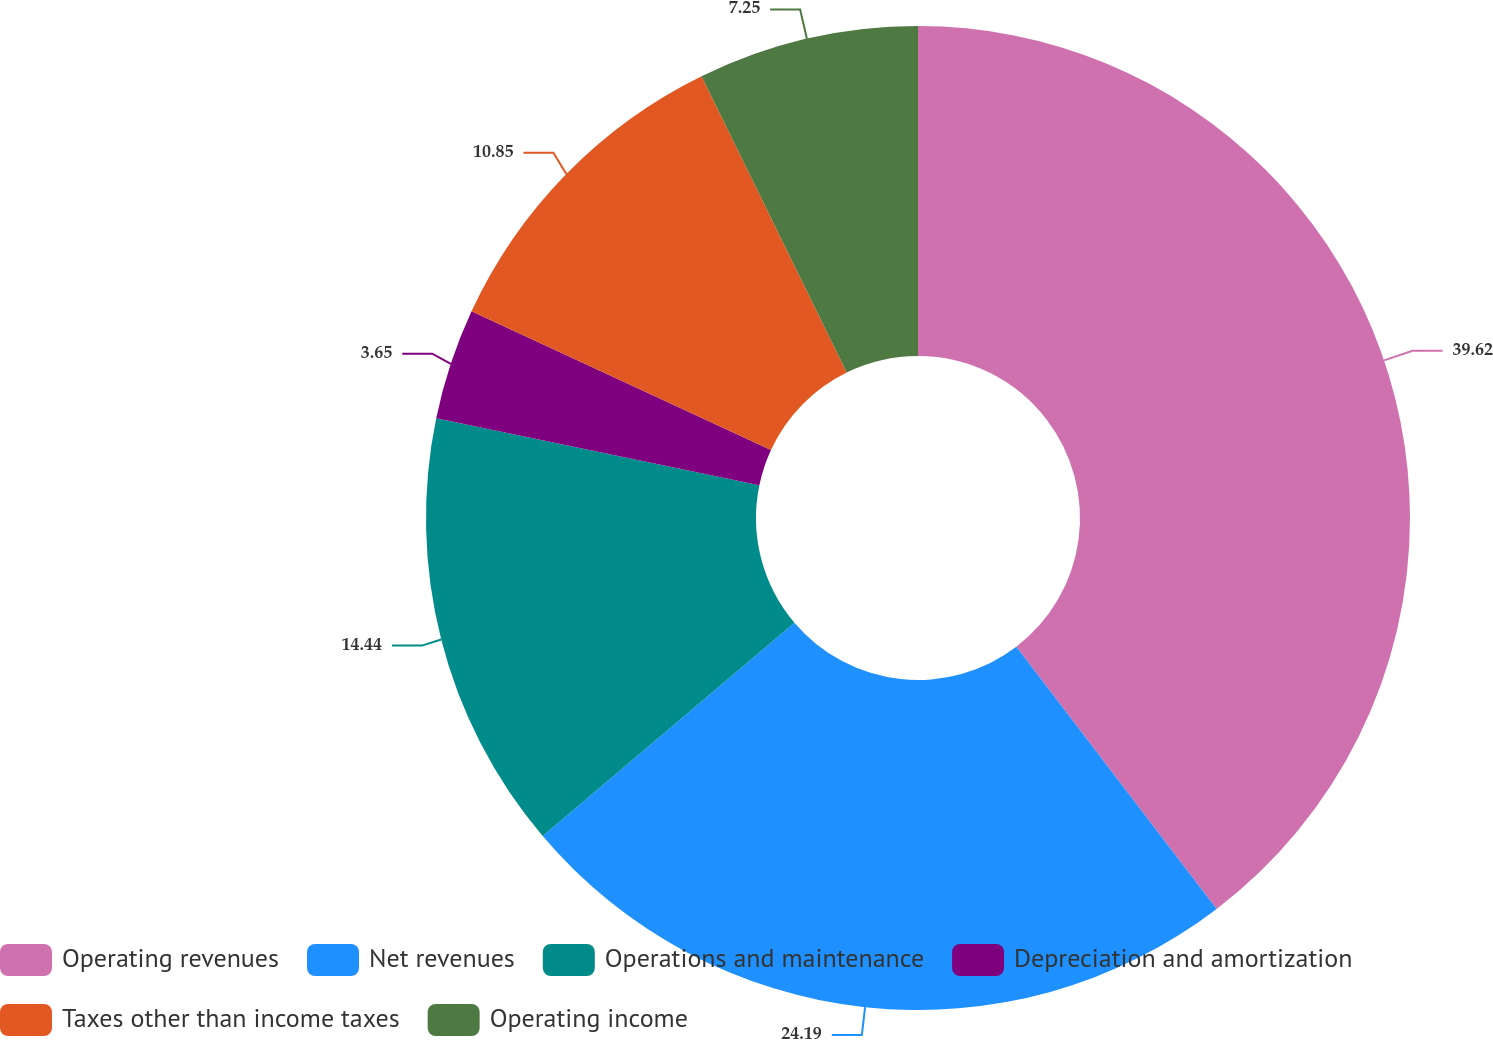<chart> <loc_0><loc_0><loc_500><loc_500><pie_chart><fcel>Operating revenues<fcel>Net revenues<fcel>Operations and maintenance<fcel>Depreciation and amortization<fcel>Taxes other than income taxes<fcel>Operating income<nl><fcel>39.62%<fcel>24.19%<fcel>14.44%<fcel>3.65%<fcel>10.85%<fcel>7.25%<nl></chart> 